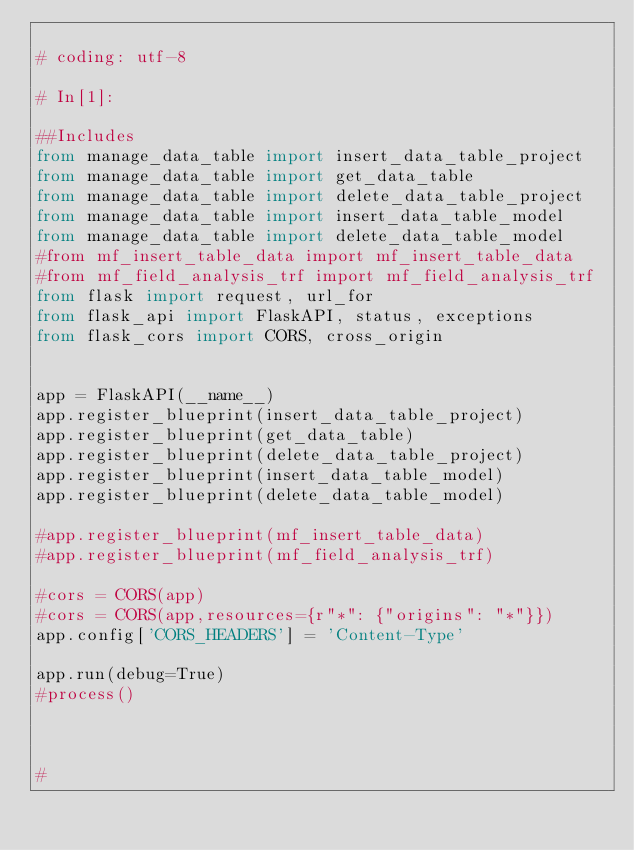<code> <loc_0><loc_0><loc_500><loc_500><_Python_>
# coding: utf-8

# In[1]:

##Includes
from manage_data_table import insert_data_table_project
from manage_data_table import get_data_table
from manage_data_table import delete_data_table_project
from manage_data_table import insert_data_table_model
from manage_data_table import delete_data_table_model
#from mf_insert_table_data import mf_insert_table_data
#from mf_field_analysis_trf import mf_field_analysis_trf
from flask import request, url_for
from flask_api import FlaskAPI, status, exceptions
from flask_cors import CORS, cross_origin


app = FlaskAPI(__name__)
app.register_blueprint(insert_data_table_project)
app.register_blueprint(get_data_table)
app.register_blueprint(delete_data_table_project)
app.register_blueprint(insert_data_table_model)
app.register_blueprint(delete_data_table_model)

#app.register_blueprint(mf_insert_table_data)
#app.register_blueprint(mf_field_analysis_trf)

#cors = CORS(app)
#cors = CORS(app,resources={r"*": {"origins": "*"}})
app.config['CORS_HEADERS'] = 'Content-Type'

app.run(debug=True)
#process()



#
</code> 